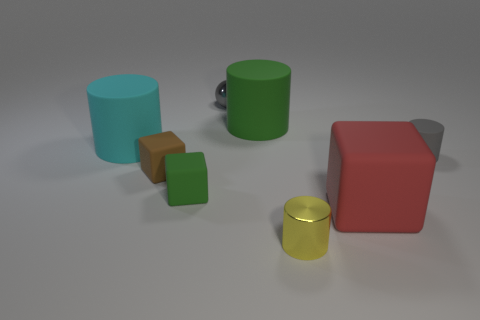Add 1 gray metallic cubes. How many objects exist? 9 Subtract all balls. How many objects are left? 7 Add 6 large cylinders. How many large cylinders are left? 8 Add 6 small rubber things. How many small rubber things exist? 9 Subtract 0 green spheres. How many objects are left? 8 Subtract all tiny green matte cubes. Subtract all brown matte objects. How many objects are left? 6 